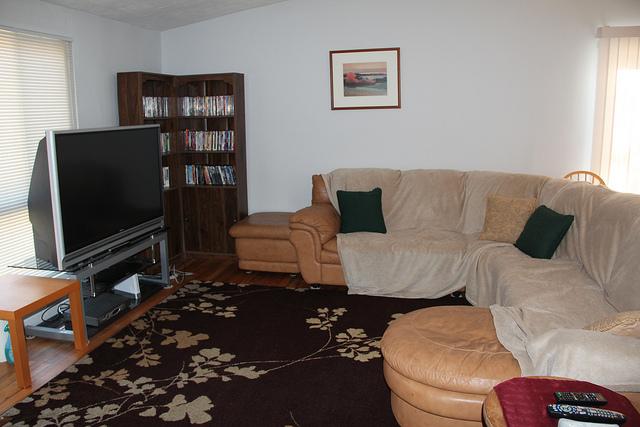What color is the TV in the living room?
Quick response, please. Black. What is the picture of on wall?
Quick response, please. Landscape. What color is the couch?
Give a very brief answer. Tan. 